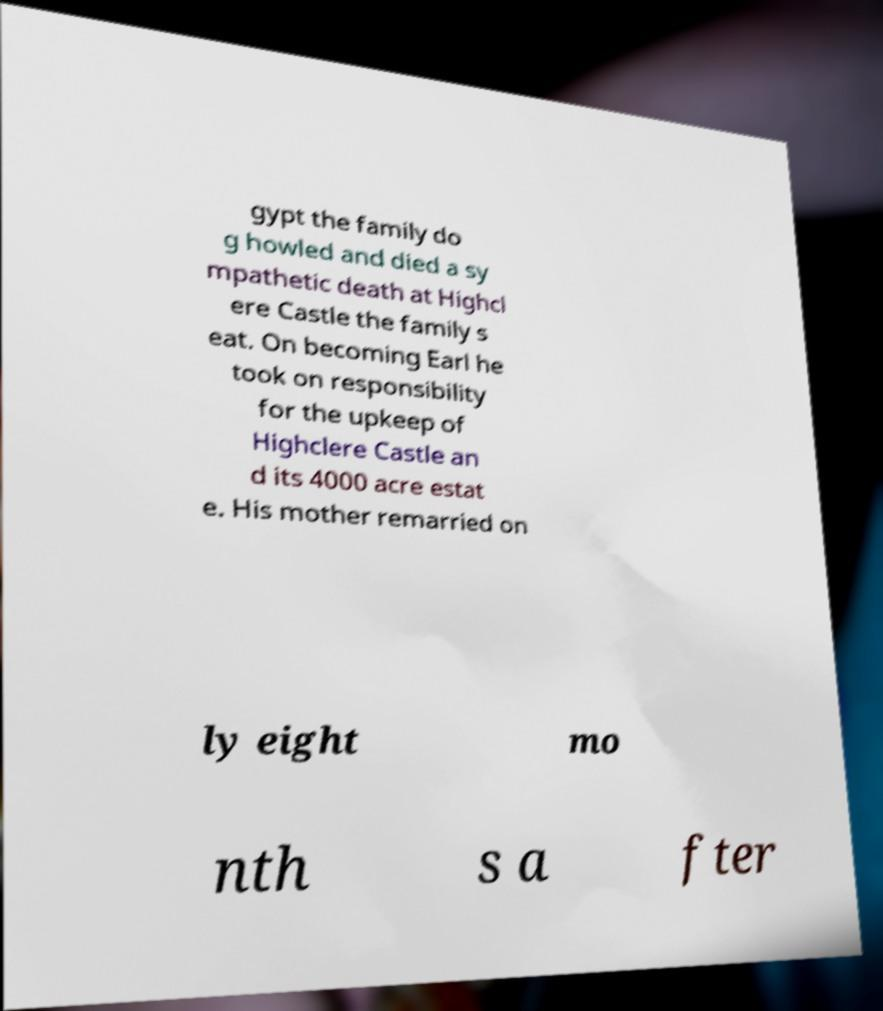What messages or text are displayed in this image? I need them in a readable, typed format. gypt the family do g howled and died a sy mpathetic death at Highcl ere Castle the family s eat. On becoming Earl he took on responsibility for the upkeep of Highclere Castle an d its 4000 acre estat e. His mother remarried on ly eight mo nth s a fter 